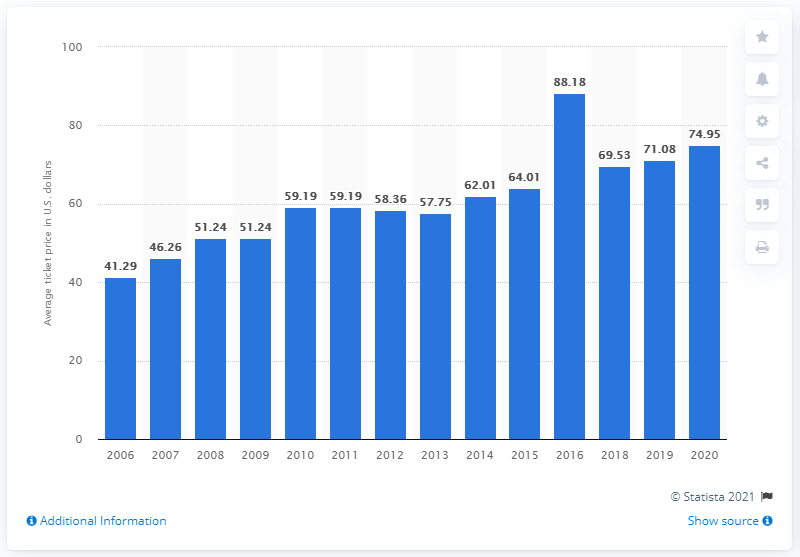Point out several critical features in this image. According to data from 2020, the average ticket price for Buffalo Bills games was approximately $74.95 per ticket. 